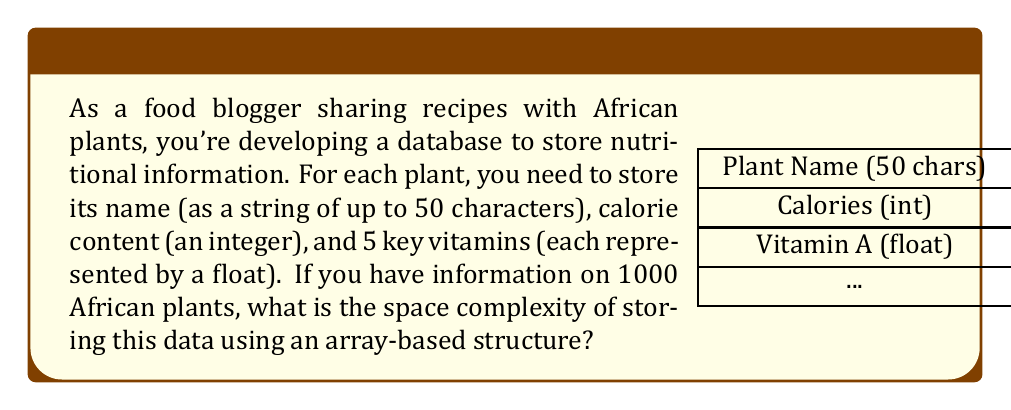Teach me how to tackle this problem. Let's break down the space requirements for each plant:

1. Plant name: 50 characters * 1 byte/character = 50 bytes
2. Calorie content: 1 integer * 4 bytes/integer = 4 bytes
3. 5 key vitamins: 5 floats * 4 bytes/float = 20 bytes

Total space per plant: 50 + 4 + 20 = 74 bytes

For 1000 plants, we multiply this by 1000:

$$ \text{Total space} = 74 \text{ bytes} \times 1000 = 74,000 \text{ bytes} $$

In big O notation, we express this as $O(n)$, where $n$ is the number of plants. This is because the space required grows linearly with the number of plants.

To see why:
Let $c = 74$ (constant bytes per plant)
Then, total space $S(n) = c \times n = 74n$

In big O notation, we drop constants, so $S(n) = O(n)$.

This linear growth is characteristic of array-based structures, where each element (plant in this case) takes up a fixed amount of space.
Answer: $O(n)$, where $n$ is the number of plants 